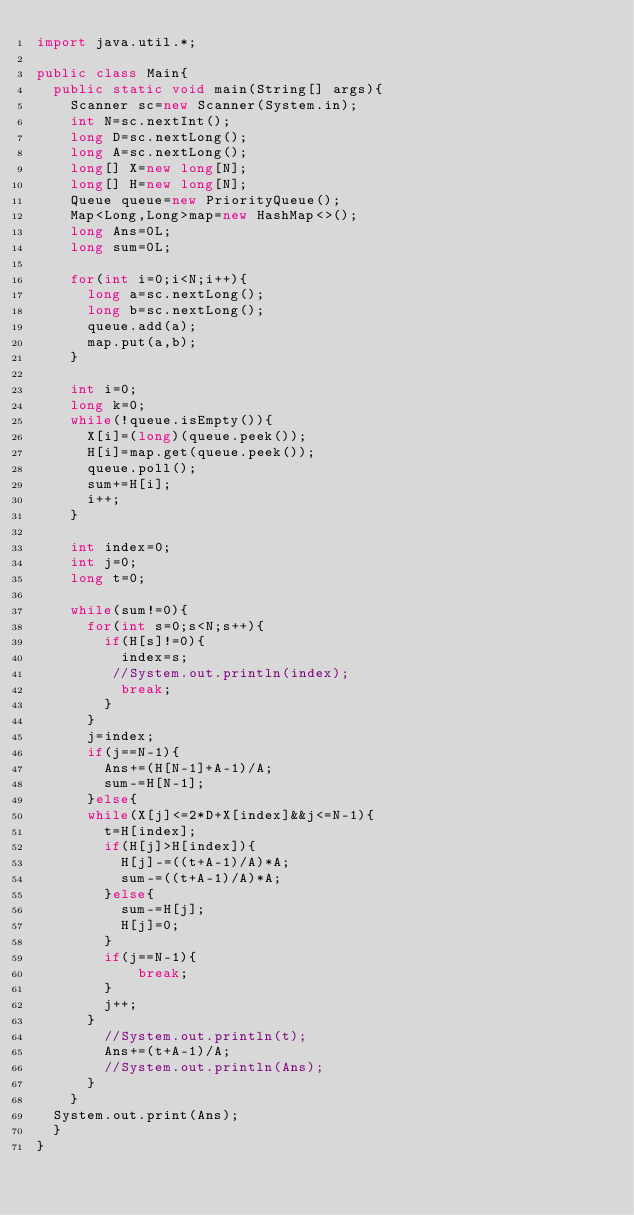<code> <loc_0><loc_0><loc_500><loc_500><_Java_>import java.util.*;

public class Main{
  public static void main(String[] args){
	Scanner sc=new Scanner(System.in);
	int N=sc.nextInt();
    long D=sc.nextLong();
    long A=sc.nextLong();
    long[] X=new long[N];
    long[] H=new long[N];
	Queue queue=new PriorityQueue();
    Map<Long,Long>map=new HashMap<>();
    long Ans=0L;
    long sum=0L;
    
    for(int i=0;i<N;i++){
      long a=sc.nextLong();
      long b=sc.nextLong();
	  queue.add(a);
      map.put(a,b);
    }
    
    int i=0;
    long k=0;
    while(!queue.isEmpty()){
      X[i]=(long)(queue.peek());
      H[i]=map.get(queue.peek());
      queue.poll();
      sum+=H[i];
      i++;
    }
    
    int index=0;
    int j=0;
    long t=0;
    
    while(sum!=0){
      for(int s=0;s<N;s++){
        if(H[s]!=0){
          index=s;
         //System.out.println(index);
          break;
        }
      }
      j=index;
      if(j==N-1){
        Ans+=(H[N-1]+A-1)/A;
        sum-=H[N-1];
      }else{
      while(X[j]<=2*D+X[index]&&j<=N-1){
        t=H[index];
        if(H[j]>H[index]){
          H[j]-=((t+A-1)/A)*A;
          sum-=((t+A-1)/A)*A;
        }else{
          sum-=H[j];
          H[j]=0;
        }
        if(j==N-1){
        	break;
        }
        j++;
      }
        //System.out.println(t);
        Ans+=(t+A-1)/A;
        //System.out.println(Ans);
      }
    }
  System.out.print(Ans);
  }
}</code> 